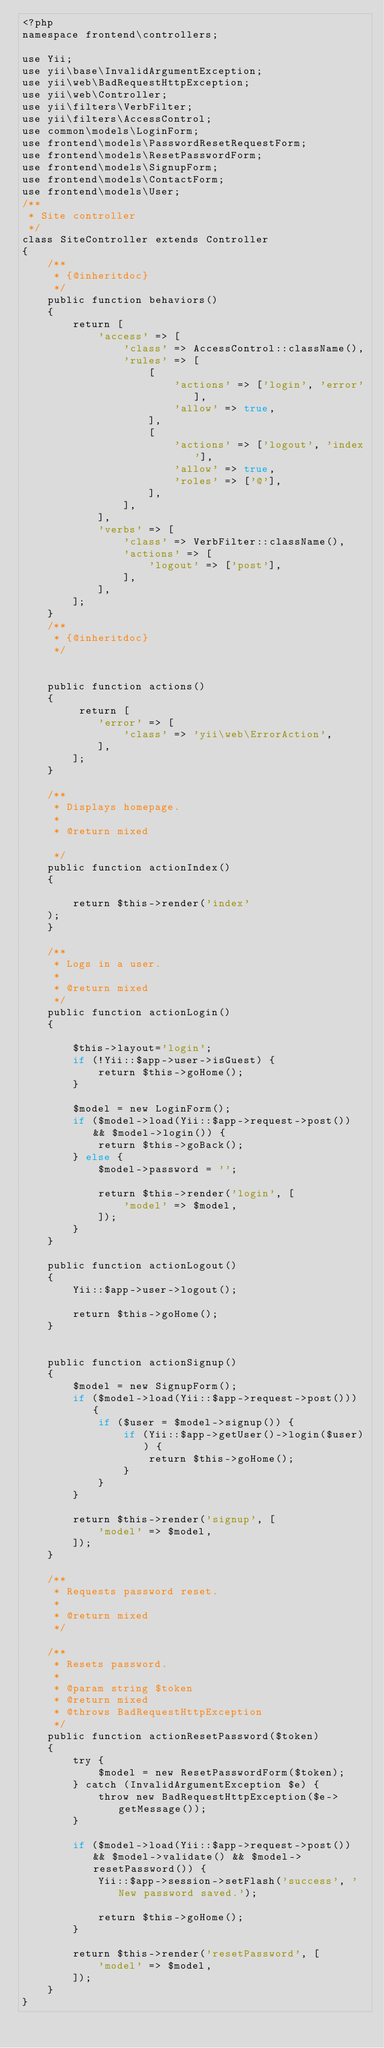<code> <loc_0><loc_0><loc_500><loc_500><_PHP_><?php
namespace frontend\controllers;

use Yii;
use yii\base\InvalidArgumentException;
use yii\web\BadRequestHttpException;
use yii\web\Controller;
use yii\filters\VerbFilter;
use yii\filters\AccessControl;
use common\models\LoginForm;
use frontend\models\PasswordResetRequestForm;
use frontend\models\ResetPasswordForm;
use frontend\models\SignupForm;
use frontend\models\ContactForm;
use frontend\models\User;
/**
 * Site controller
 */
class SiteController extends Controller
{
    /**
     * {@inheritdoc}
     */
    public function behaviors()
    {
        return [
            'access' => [
                'class' => AccessControl::className(),
                'rules' => [
                    [
                        'actions' => ['login', 'error'],
                        'allow' => true,
                    ],
                    [
                        'actions' => ['logout', 'index'],
                        'allow' => true,
                        'roles' => ['@'],
                    ],
                ],
            ],
            'verbs' => [
                'class' => VerbFilter::className(),
                'actions' => [
                    'logout' => ['post'],
                ],
            ],
        ];
    }
    /**
     * {@inheritdoc}
     */


    public function actions()
    {
         return [
            'error' => [
                'class' => 'yii\web\ErrorAction',
            ],
        ];
    }

    /**
     * Displays homepage.
     *
     * @return mixed

     */
    public function actionIndex()
    {
     
        return $this->render('index'
    );
    }

    /**
     * Logs in a user.
     *
     * @return mixed
     */
    public function actionLogin()
    {
        
        $this->layout='login';
        if (!Yii::$app->user->isGuest) {
            return $this->goHome();
        }

        $model = new LoginForm();
        if ($model->load(Yii::$app->request->post()) && $model->login()) {
            return $this->goBack();
        } else {
            $model->password = '';

            return $this->render('login', [
                'model' => $model,
            ]);
        }
    }

    public function actionLogout()
    {
        Yii::$app->user->logout();

        return $this->goHome();
    }

   
    public function actionSignup()
    {
        $model = new SignupForm();
        if ($model->load(Yii::$app->request->post())) {
            if ($user = $model->signup()) {
                if (Yii::$app->getUser()->login($user)) {
                    return $this->goHome();
                }
            }
        }

        return $this->render('signup', [
            'model' => $model,
        ]);
    }

    /**
     * Requests password reset.
     *
     * @return mixed
     */

    /**
     * Resets password.
     *
     * @param string $token
     * @return mixed
     * @throws BadRequestHttpException
     */
    public function actionResetPassword($token)
    {
        try {
            $model = new ResetPasswordForm($token);
        } catch (InvalidArgumentException $e) {
            throw new BadRequestHttpException($e->getMessage());
        }

        if ($model->load(Yii::$app->request->post()) && $model->validate() && $model->resetPassword()) {
            Yii::$app->session->setFlash('success', 'New password saved.');

            return $this->goHome();
        }

        return $this->render('resetPassword', [
            'model' => $model,
        ]);
    }
}
</code> 